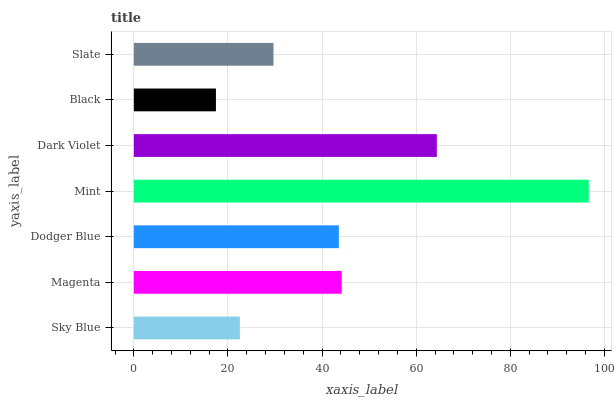Is Black the minimum?
Answer yes or no. Yes. Is Mint the maximum?
Answer yes or no. Yes. Is Magenta the minimum?
Answer yes or no. No. Is Magenta the maximum?
Answer yes or no. No. Is Magenta greater than Sky Blue?
Answer yes or no. Yes. Is Sky Blue less than Magenta?
Answer yes or no. Yes. Is Sky Blue greater than Magenta?
Answer yes or no. No. Is Magenta less than Sky Blue?
Answer yes or no. No. Is Dodger Blue the high median?
Answer yes or no. Yes. Is Dodger Blue the low median?
Answer yes or no. Yes. Is Sky Blue the high median?
Answer yes or no. No. Is Black the low median?
Answer yes or no. No. 